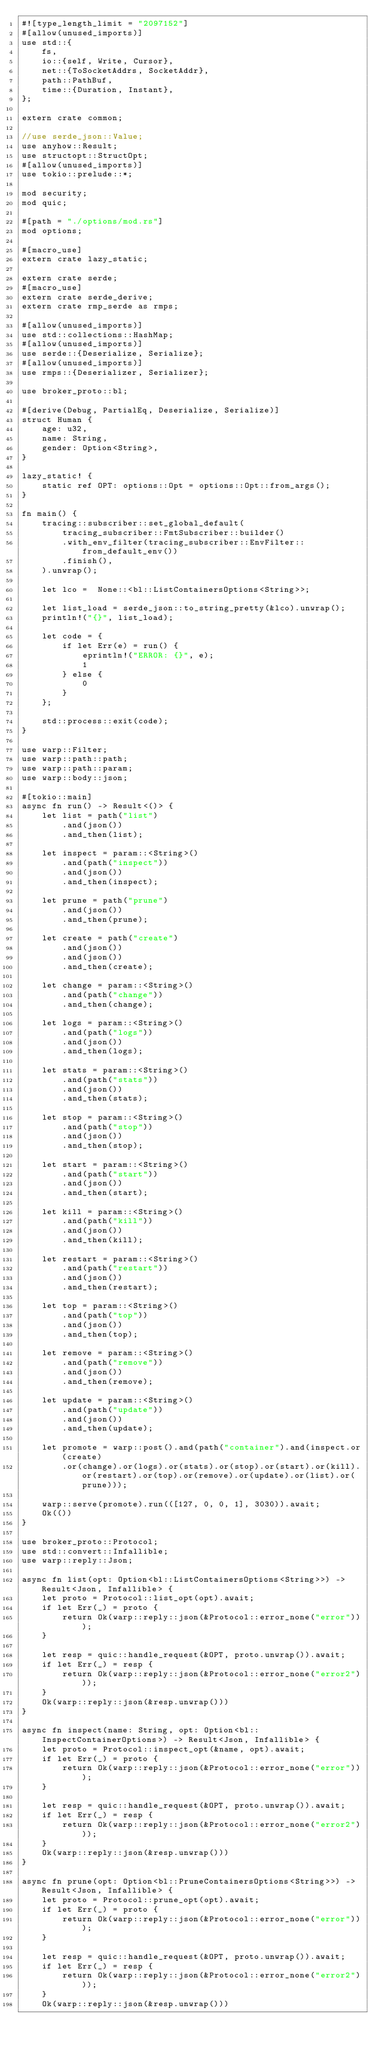Convert code to text. <code><loc_0><loc_0><loc_500><loc_500><_Rust_>#![type_length_limit = "2097152"]
#[allow(unused_imports)]
use std::{
    fs,
    io::{self, Write, Cursor},
    net::{ToSocketAddrs, SocketAddr},
    path::PathBuf,
    time::{Duration, Instant},
};

extern crate common;

//use serde_json::Value;
use anyhow::Result;
use structopt::StructOpt;
#[allow(unused_imports)]
use tokio::prelude::*;

mod security;
mod quic;

#[path = "./options/mod.rs"]
mod options;

#[macro_use]
extern crate lazy_static;

extern crate serde;
#[macro_use]
extern crate serde_derive;
extern crate rmp_serde as rmps;

#[allow(unused_imports)]
use std::collections::HashMap;
#[allow(unused_imports)]
use serde::{Deserialize, Serialize};
#[allow(unused_imports)]
use rmps::{Deserializer, Serializer};

use broker_proto::bl;

#[derive(Debug, PartialEq, Deserialize, Serialize)]
struct Human {
    age: u32,
    name: String,
    gender: Option<String>,
}

lazy_static! {
    static ref OPT: options::Opt = options::Opt::from_args();
}

fn main() {
    tracing::subscriber::set_global_default(
        tracing_subscriber::FmtSubscriber::builder()
        .with_env_filter(tracing_subscriber::EnvFilter::from_default_env())
        .finish(),
    ).unwrap();

    let lco =  None::<bl::ListContainersOptions<String>>;

    let list_load = serde_json::to_string_pretty(&lco).unwrap();
    println!("{}", list_load);
   
    let code = {
        if let Err(e) = run() {
            eprintln!("ERROR: {}", e);
            1
        } else {
            0
        }
    };

    std::process::exit(code);
}

use warp::Filter;
use warp::path::path;
use warp::path::param;
use warp::body::json;

#[tokio::main]
async fn run() -> Result<()> {
    let list = path("list")
        .and(json())
        .and_then(list);

    let inspect = param::<String>()
        .and(path("inspect"))    
        .and(json())
        .and_then(inspect);

    let prune = path("prune")
        .and(json())
        .and_then(prune);

    let create = path("create")
        .and(json())
        .and(json())
        .and_then(create);

    let change = param::<String>()
        .and(path("change"))
        .and_then(change);

    let logs = param::<String>()
        .and(path("logs"))
        .and(json())
        .and_then(logs);

    let stats = param::<String>()
        .and(path("stats"))
        .and(json())
        .and_then(stats);
    
    let stop = param::<String>()
        .and(path("stop"))
        .and(json())
        .and_then(stop);

    let start = param::<String>()
        .and(path("start"))
        .and(json())
        .and_then(start);

    let kill = param::<String>()
        .and(path("kill"))
        .and(json())
        .and_then(kill);

    let restart = param::<String>()
        .and(path("restart"))
        .and(json())
        .and_then(restart);

    let top = param::<String>()
        .and(path("top"))
        .and(json())
        .and_then(top);

    let remove = param::<String>()
        .and(path("remove"))
        .and(json())
        .and_then(remove);

    let update = param::<String>()
        .and(path("update"))
        .and(json())
        .and_then(update);

    let promote = warp::post().and(path("container").and(inspect.or(create)
        .or(change).or(logs).or(stats).or(stop).or(start).or(kill).or(restart).or(top).or(remove).or(update).or(list).or(prune)));

    warp::serve(promote).run(([127, 0, 0, 1], 3030)).await;
    Ok(())
}

use broker_proto::Protocol;
use std::convert::Infallible;
use warp::reply::Json;

async fn list(opt: Option<bl::ListContainersOptions<String>>) -> Result<Json, Infallible> {
    let proto = Protocol::list_opt(opt).await;
    if let Err(_) = proto {
        return Ok(warp::reply::json(&Protocol::error_none("error")));
    }

    let resp = quic::handle_request(&OPT, proto.unwrap()).await;
    if let Err(_) = resp {
        return Ok(warp::reply::json(&Protocol::error_none("error2")));
    }
    Ok(warp::reply::json(&resp.unwrap()))
}

async fn inspect(name: String, opt: Option<bl::InspectContainerOptions>) -> Result<Json, Infallible> {
    let proto = Protocol::inspect_opt(&name, opt).await;
    if let Err(_) = proto {
        return Ok(warp::reply::json(&Protocol::error_none("error")));
    }

    let resp = quic::handle_request(&OPT, proto.unwrap()).await;
    if let Err(_) = resp {
        return Ok(warp::reply::json(&Protocol::error_none("error2")));
    }
    Ok(warp::reply::json(&resp.unwrap()))
}

async fn prune(opt: Option<bl::PruneContainersOptions<String>>) -> Result<Json, Infallible> {
    let proto = Protocol::prune_opt(opt).await;
    if let Err(_) = proto {
        return Ok(warp::reply::json(&Protocol::error_none("error")));
    }

    let resp = quic::handle_request(&OPT, proto.unwrap()).await;
    if let Err(_) = resp {
        return Ok(warp::reply::json(&Protocol::error_none("error2")));
    }
    Ok(warp::reply::json(&resp.unwrap()))</code> 